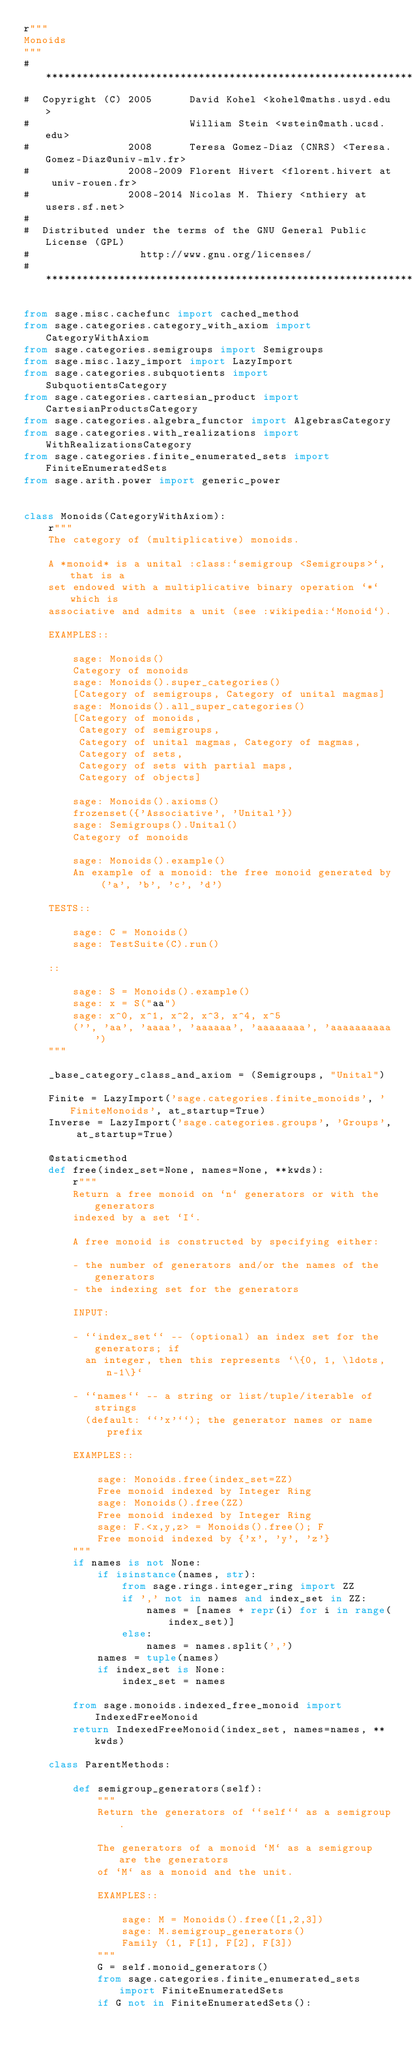Convert code to text. <code><loc_0><loc_0><loc_500><loc_500><_Python_>r"""
Monoids
"""
#*****************************************************************************
#  Copyright (C) 2005      David Kohel <kohel@maths.usyd.edu>
#                          William Stein <wstein@math.ucsd.edu>
#                2008      Teresa Gomez-Diaz (CNRS) <Teresa.Gomez-Diaz@univ-mlv.fr>
#                2008-2009 Florent Hivert <florent.hivert at univ-rouen.fr>
#                2008-2014 Nicolas M. Thiery <nthiery at users.sf.net>
#
#  Distributed under the terms of the GNU General Public License (GPL)
#                  http://www.gnu.org/licenses/
#******************************************************************************

from sage.misc.cachefunc import cached_method
from sage.categories.category_with_axiom import CategoryWithAxiom
from sage.categories.semigroups import Semigroups
from sage.misc.lazy_import import LazyImport
from sage.categories.subquotients import SubquotientsCategory
from sage.categories.cartesian_product import CartesianProductsCategory
from sage.categories.algebra_functor import AlgebrasCategory
from sage.categories.with_realizations import WithRealizationsCategory
from sage.categories.finite_enumerated_sets import FiniteEnumeratedSets
from sage.arith.power import generic_power


class Monoids(CategoryWithAxiom):
    r"""
    The category of (multiplicative) monoids.

    A *monoid* is a unital :class:`semigroup <Semigroups>`, that is a
    set endowed with a multiplicative binary operation `*` which is
    associative and admits a unit (see :wikipedia:`Monoid`).

    EXAMPLES::

        sage: Monoids()
        Category of monoids
        sage: Monoids().super_categories()
        [Category of semigroups, Category of unital magmas]
        sage: Monoids().all_super_categories()
        [Category of monoids,
         Category of semigroups,
         Category of unital magmas, Category of magmas,
         Category of sets,
         Category of sets with partial maps,
         Category of objects]

        sage: Monoids().axioms()
        frozenset({'Associative', 'Unital'})
        sage: Semigroups().Unital()
        Category of monoids

        sage: Monoids().example()
        An example of a monoid: the free monoid generated by ('a', 'b', 'c', 'd')

    TESTS::

        sage: C = Monoids()
        sage: TestSuite(C).run()

    ::

        sage: S = Monoids().example()
        sage: x = S("aa")
        sage: x^0, x^1, x^2, x^3, x^4, x^5
        ('', 'aa', 'aaaa', 'aaaaaa', 'aaaaaaaa', 'aaaaaaaaaa')
    """

    _base_category_class_and_axiom = (Semigroups, "Unital")

    Finite = LazyImport('sage.categories.finite_monoids', 'FiniteMonoids', at_startup=True)
    Inverse = LazyImport('sage.categories.groups', 'Groups', at_startup=True)

    @staticmethod
    def free(index_set=None, names=None, **kwds):
        r"""
        Return a free monoid on `n` generators or with the generators
        indexed by a set `I`.

        A free monoid is constructed by specifying either:

        - the number of generators and/or the names of the generators
        - the indexing set for the generators

        INPUT:

        - ``index_set`` -- (optional) an index set for the generators; if
          an integer, then this represents `\{0, 1, \ldots, n-1\}`

        - ``names`` -- a string or list/tuple/iterable of strings
          (default: ``'x'``); the generator names or name prefix

        EXAMPLES::

            sage: Monoids.free(index_set=ZZ)
            Free monoid indexed by Integer Ring
            sage: Monoids().free(ZZ)
            Free monoid indexed by Integer Ring
            sage: F.<x,y,z> = Monoids().free(); F
            Free monoid indexed by {'x', 'y', 'z'}
        """
        if names is not None:
            if isinstance(names, str):
                from sage.rings.integer_ring import ZZ
                if ',' not in names and index_set in ZZ:
                    names = [names + repr(i) for i in range(index_set)]
                else:
                    names = names.split(',')
            names = tuple(names)
            if index_set is None:
                index_set = names

        from sage.monoids.indexed_free_monoid import IndexedFreeMonoid
        return IndexedFreeMonoid(index_set, names=names, **kwds)

    class ParentMethods:

        def semigroup_generators(self):
            """
            Return the generators of ``self`` as a semigroup.

            The generators of a monoid `M` as a semigroup are the generators
            of `M` as a monoid and the unit.

            EXAMPLES::

                sage: M = Monoids().free([1,2,3])
                sage: M.semigroup_generators()
                Family (1, F[1], F[2], F[3])
            """
            G = self.monoid_generators()
            from sage.categories.finite_enumerated_sets import FiniteEnumeratedSets
            if G not in FiniteEnumeratedSets():</code> 